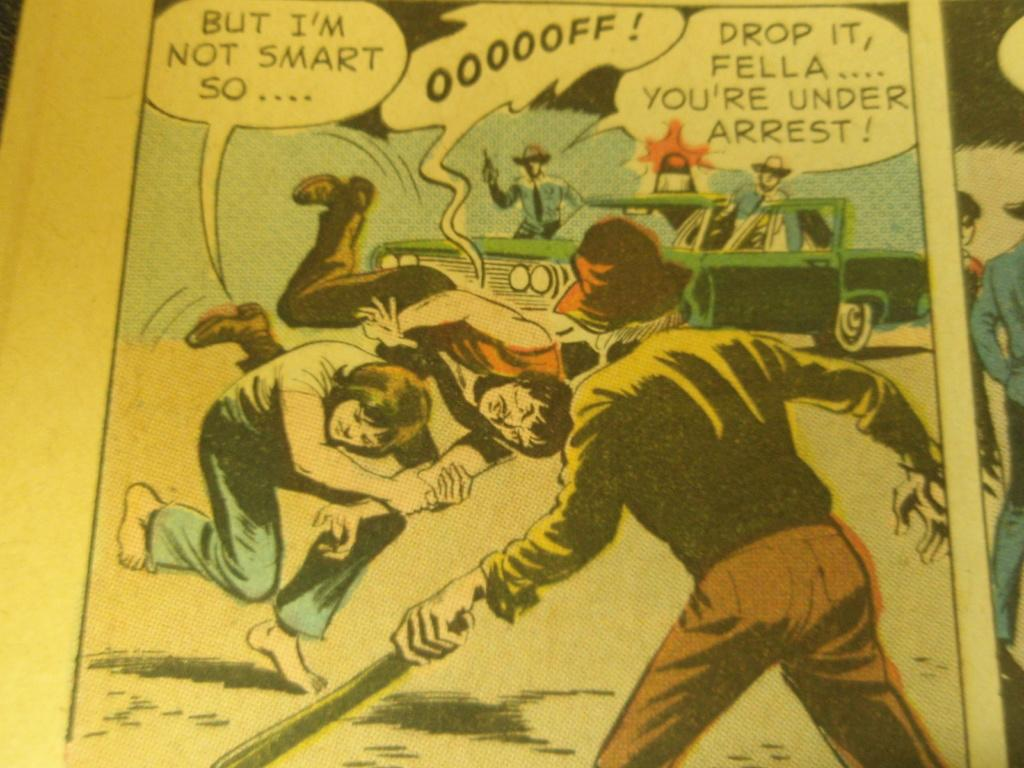<image>
Summarize the visual content of the image. The person in the comic yells drop it. 